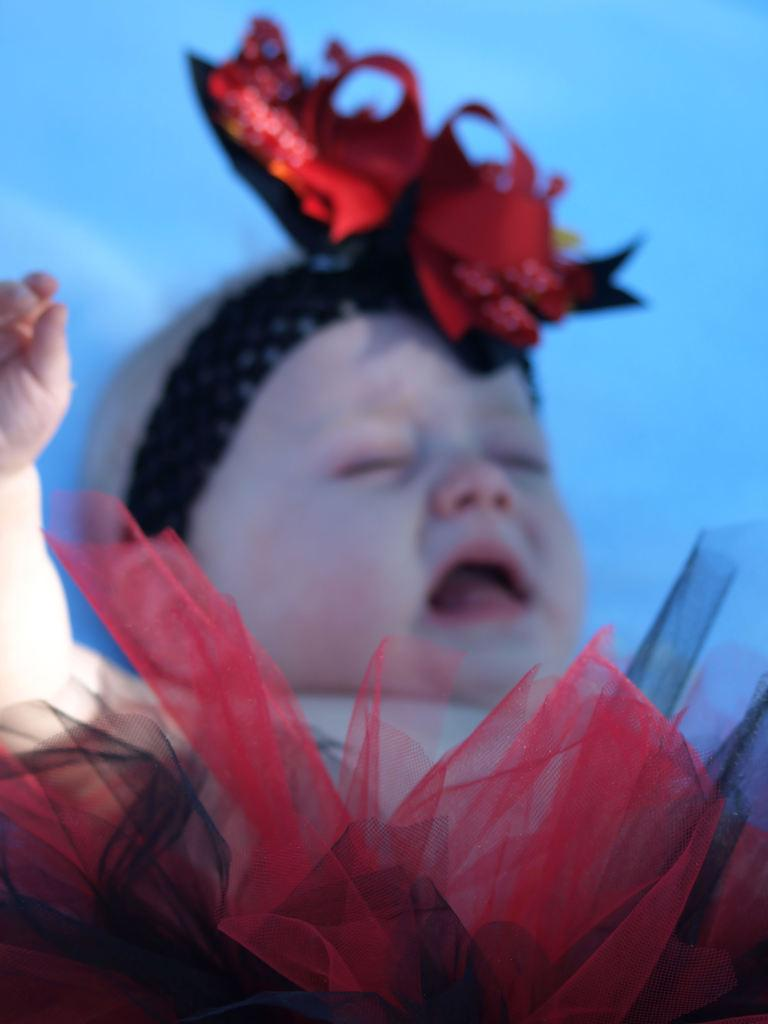What is the main subject of the picture? The main subject of the picture is a baby. What is the baby lying on? The baby is lying on a blue bed sheet. What is the baby wearing? The baby is wearing a red dress. What accessory is the baby wearing on their head? The baby has a hair band. What type of secretary is present in the image? There is no secretary present in the image; it features a baby lying on a blue bed sheet and wearing a red dress with a hair band. 